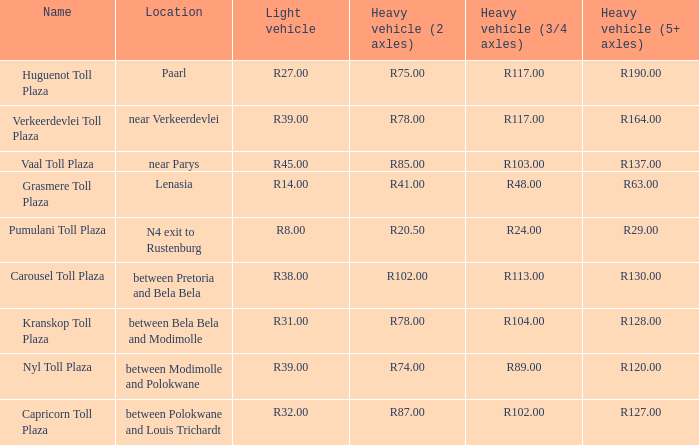What is the toll for light vehicles at the plaza where the toll for heavy vehicles with 2 axles is r87.00? R32.00. 